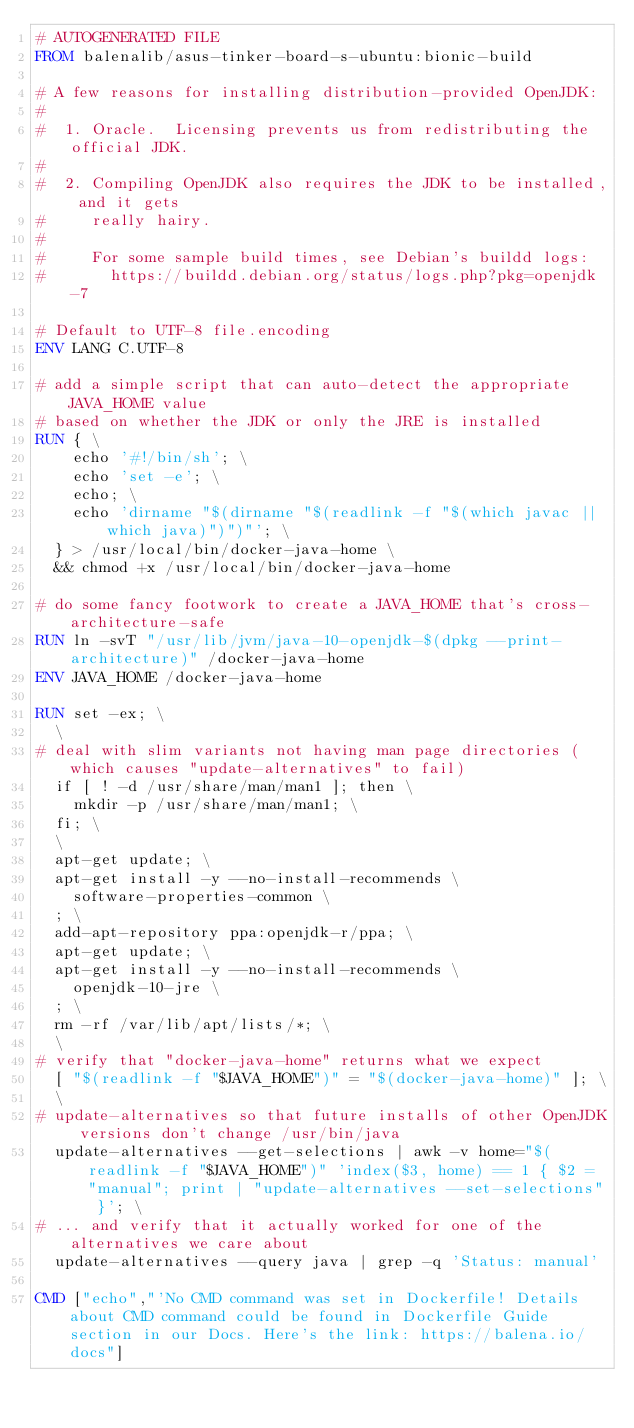Convert code to text. <code><loc_0><loc_0><loc_500><loc_500><_Dockerfile_># AUTOGENERATED FILE
FROM balenalib/asus-tinker-board-s-ubuntu:bionic-build

# A few reasons for installing distribution-provided OpenJDK:
#
#  1. Oracle.  Licensing prevents us from redistributing the official JDK.
#
#  2. Compiling OpenJDK also requires the JDK to be installed, and it gets
#     really hairy.
#
#     For some sample build times, see Debian's buildd logs:
#       https://buildd.debian.org/status/logs.php?pkg=openjdk-7

# Default to UTF-8 file.encoding
ENV LANG C.UTF-8

# add a simple script that can auto-detect the appropriate JAVA_HOME value
# based on whether the JDK or only the JRE is installed
RUN { \
		echo '#!/bin/sh'; \
		echo 'set -e'; \
		echo; \
		echo 'dirname "$(dirname "$(readlink -f "$(which javac || which java)")")"'; \
	} > /usr/local/bin/docker-java-home \
	&& chmod +x /usr/local/bin/docker-java-home

# do some fancy footwork to create a JAVA_HOME that's cross-architecture-safe
RUN ln -svT "/usr/lib/jvm/java-10-openjdk-$(dpkg --print-architecture)" /docker-java-home
ENV JAVA_HOME /docker-java-home

RUN set -ex; \
	\
# deal with slim variants not having man page directories (which causes "update-alternatives" to fail)
	if [ ! -d /usr/share/man/man1 ]; then \
		mkdir -p /usr/share/man/man1; \
	fi; \
	\
	apt-get update; \
	apt-get install -y --no-install-recommends \
		software-properties-common \
	; \
	add-apt-repository ppa:openjdk-r/ppa; \
	apt-get update; \
	apt-get install -y --no-install-recommends \
		openjdk-10-jre \
	; \
	rm -rf /var/lib/apt/lists/*; \
	\
# verify that "docker-java-home" returns what we expect
	[ "$(readlink -f "$JAVA_HOME")" = "$(docker-java-home)" ]; \
	\
# update-alternatives so that future installs of other OpenJDK versions don't change /usr/bin/java
	update-alternatives --get-selections | awk -v home="$(readlink -f "$JAVA_HOME")" 'index($3, home) == 1 { $2 = "manual"; print | "update-alternatives --set-selections" }'; \
# ... and verify that it actually worked for one of the alternatives we care about
	update-alternatives --query java | grep -q 'Status: manual'

CMD ["echo","'No CMD command was set in Dockerfile! Details about CMD command could be found in Dockerfile Guide section in our Docs. Here's the link: https://balena.io/docs"]</code> 